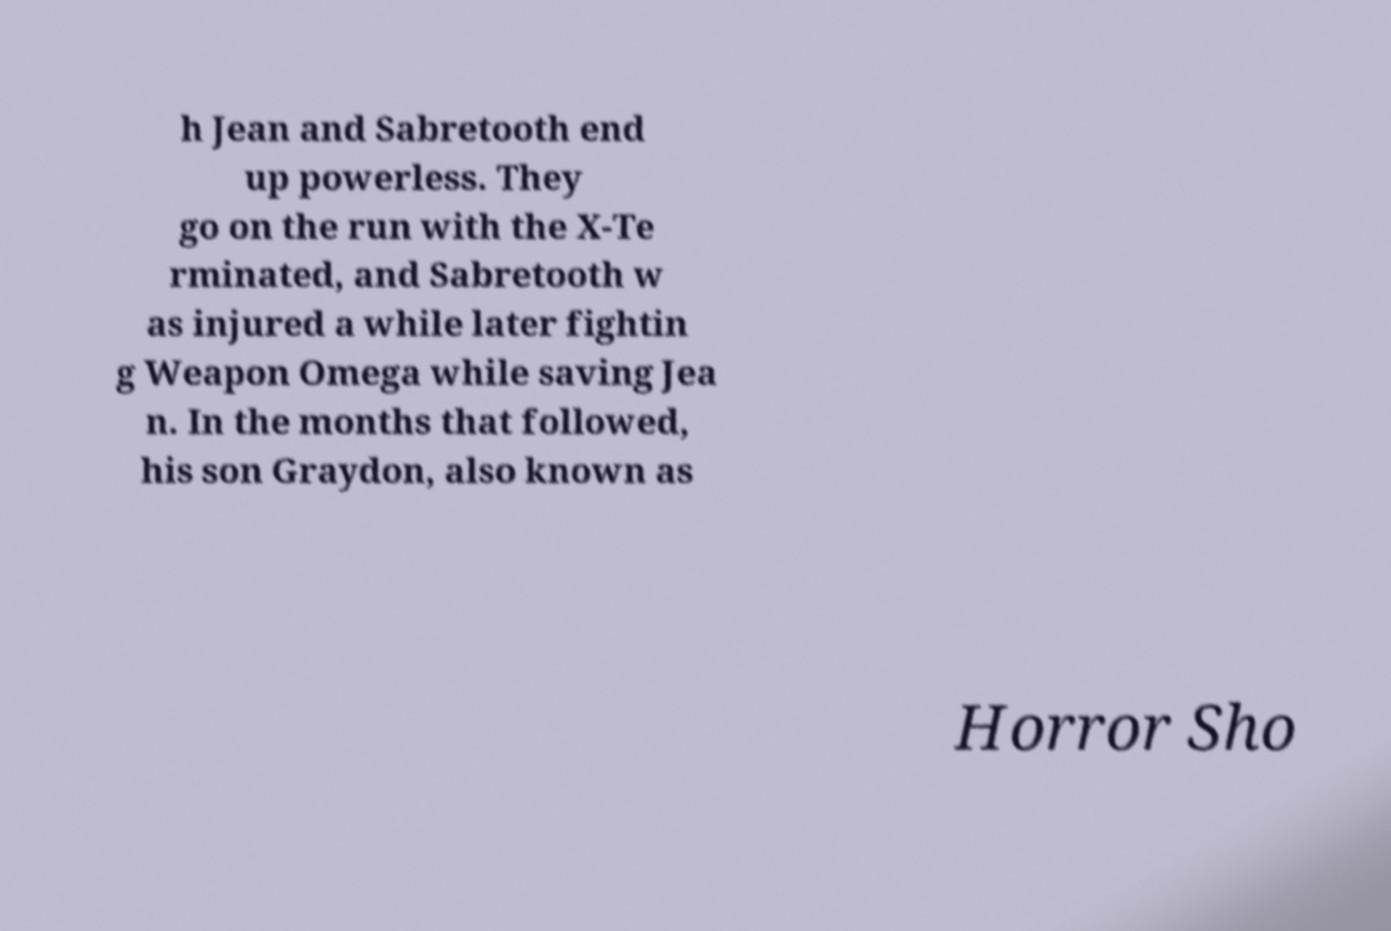Could you extract and type out the text from this image? h Jean and Sabretooth end up powerless. They go on the run with the X-Te rminated, and Sabretooth w as injured a while later fightin g Weapon Omega while saving Jea n. In the months that followed, his son Graydon, also known as Horror Sho 